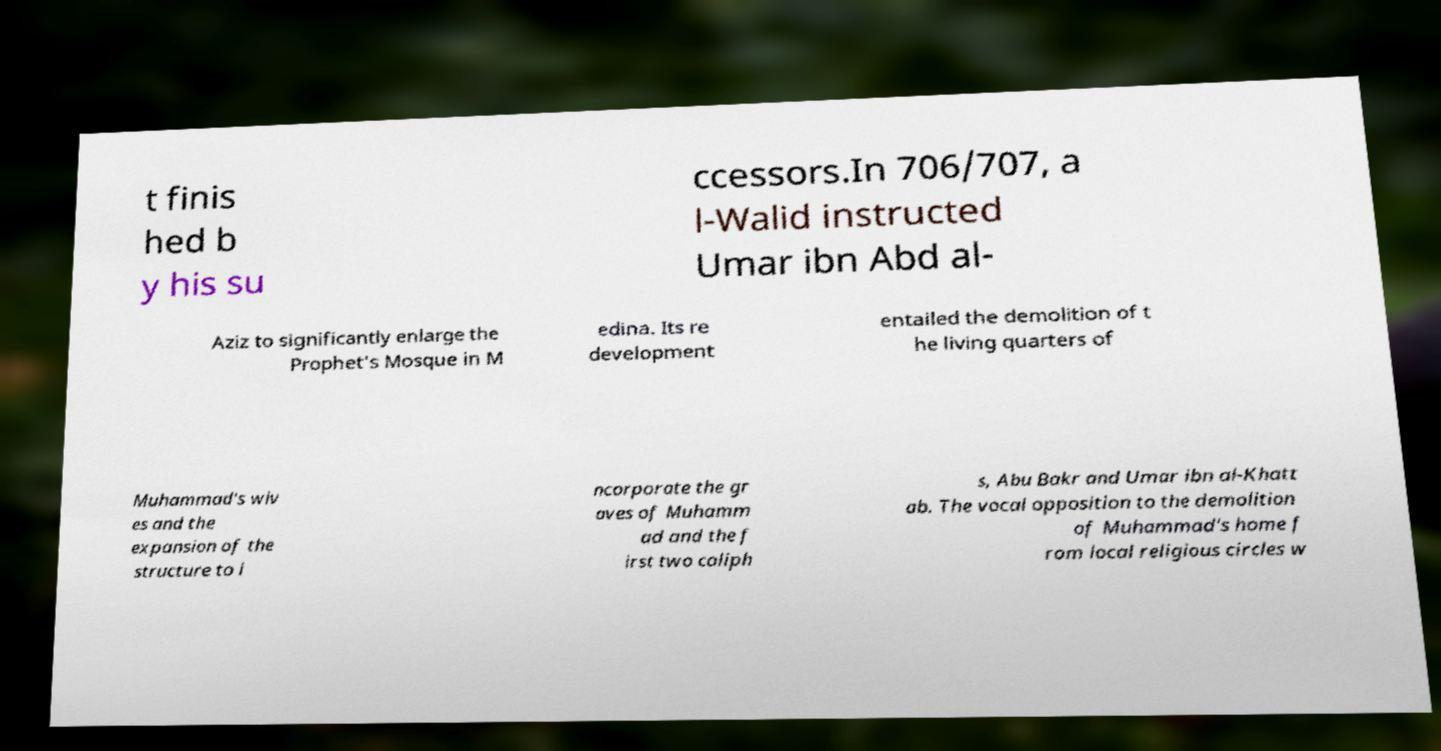Please read and relay the text visible in this image. What does it say? t finis hed b y his su ccessors.In 706/707, a l-Walid instructed Umar ibn Abd al- Aziz to significantly enlarge the Prophet's Mosque in M edina. Its re development entailed the demolition of t he living quarters of Muhammad's wiv es and the expansion of the structure to i ncorporate the gr aves of Muhamm ad and the f irst two caliph s, Abu Bakr and Umar ibn al-Khatt ab. The vocal opposition to the demolition of Muhammad's home f rom local religious circles w 